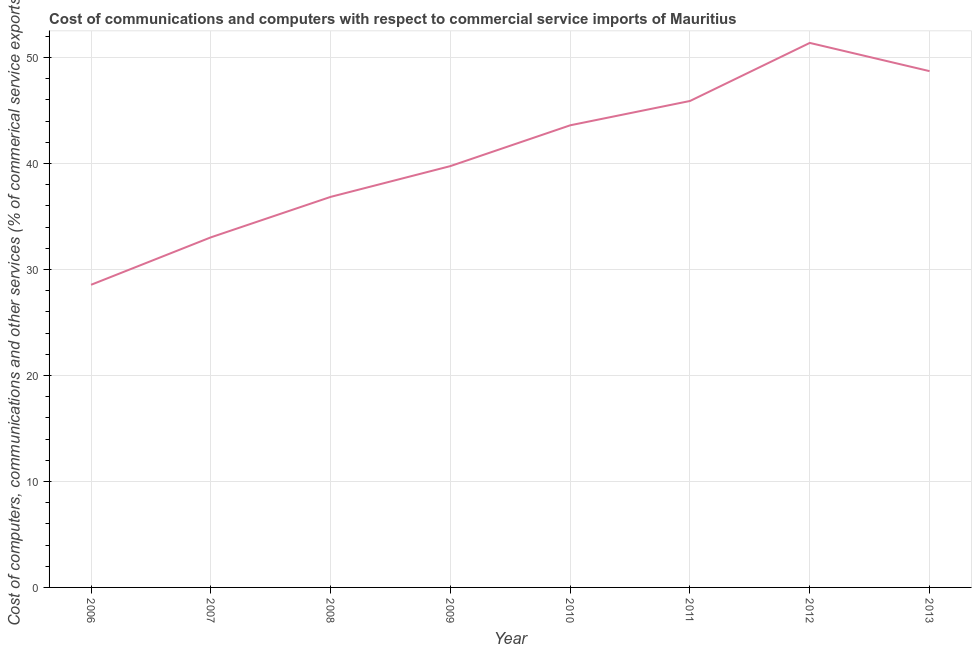What is the cost of communications in 2009?
Your answer should be very brief. 39.76. Across all years, what is the maximum  computer and other services?
Make the answer very short. 51.38. Across all years, what is the minimum  computer and other services?
Your response must be concise. 28.56. What is the sum of the  computer and other services?
Your response must be concise. 327.82. What is the difference between the cost of communications in 2011 and 2013?
Ensure brevity in your answer.  -2.82. What is the average cost of communications per year?
Provide a succinct answer. 40.98. What is the median cost of communications?
Give a very brief answer. 41.68. What is the ratio of the  computer and other services in 2009 to that in 2012?
Your response must be concise. 0.77. Is the cost of communications in 2007 less than that in 2009?
Keep it short and to the point. Yes. What is the difference between the highest and the second highest cost of communications?
Give a very brief answer. 2.66. Is the sum of the cost of communications in 2006 and 2010 greater than the maximum cost of communications across all years?
Your answer should be very brief. Yes. What is the difference between the highest and the lowest cost of communications?
Your response must be concise. 22.82. In how many years, is the cost of communications greater than the average cost of communications taken over all years?
Your answer should be very brief. 4. How many years are there in the graph?
Provide a short and direct response. 8. What is the difference between two consecutive major ticks on the Y-axis?
Keep it short and to the point. 10. What is the title of the graph?
Keep it short and to the point. Cost of communications and computers with respect to commercial service imports of Mauritius. What is the label or title of the X-axis?
Offer a very short reply. Year. What is the label or title of the Y-axis?
Offer a very short reply. Cost of computers, communications and other services (% of commerical service exports). What is the Cost of computers, communications and other services (% of commerical service exports) of 2006?
Provide a succinct answer. 28.56. What is the Cost of computers, communications and other services (% of commerical service exports) of 2007?
Your answer should be compact. 33.04. What is the Cost of computers, communications and other services (% of commerical service exports) of 2008?
Offer a very short reply. 36.85. What is the Cost of computers, communications and other services (% of commerical service exports) of 2009?
Provide a succinct answer. 39.76. What is the Cost of computers, communications and other services (% of commerical service exports) in 2010?
Give a very brief answer. 43.61. What is the Cost of computers, communications and other services (% of commerical service exports) in 2011?
Give a very brief answer. 45.9. What is the Cost of computers, communications and other services (% of commerical service exports) in 2012?
Your answer should be compact. 51.38. What is the Cost of computers, communications and other services (% of commerical service exports) of 2013?
Offer a very short reply. 48.72. What is the difference between the Cost of computers, communications and other services (% of commerical service exports) in 2006 and 2007?
Keep it short and to the point. -4.48. What is the difference between the Cost of computers, communications and other services (% of commerical service exports) in 2006 and 2008?
Offer a terse response. -8.3. What is the difference between the Cost of computers, communications and other services (% of commerical service exports) in 2006 and 2009?
Provide a short and direct response. -11.2. What is the difference between the Cost of computers, communications and other services (% of commerical service exports) in 2006 and 2010?
Keep it short and to the point. -15.05. What is the difference between the Cost of computers, communications and other services (% of commerical service exports) in 2006 and 2011?
Your answer should be very brief. -17.35. What is the difference between the Cost of computers, communications and other services (% of commerical service exports) in 2006 and 2012?
Your answer should be very brief. -22.82. What is the difference between the Cost of computers, communications and other services (% of commerical service exports) in 2006 and 2013?
Offer a terse response. -20.16. What is the difference between the Cost of computers, communications and other services (% of commerical service exports) in 2007 and 2008?
Your answer should be compact. -3.82. What is the difference between the Cost of computers, communications and other services (% of commerical service exports) in 2007 and 2009?
Ensure brevity in your answer.  -6.72. What is the difference between the Cost of computers, communications and other services (% of commerical service exports) in 2007 and 2010?
Your response must be concise. -10.57. What is the difference between the Cost of computers, communications and other services (% of commerical service exports) in 2007 and 2011?
Make the answer very short. -12.87. What is the difference between the Cost of computers, communications and other services (% of commerical service exports) in 2007 and 2012?
Your response must be concise. -18.35. What is the difference between the Cost of computers, communications and other services (% of commerical service exports) in 2007 and 2013?
Your response must be concise. -15.68. What is the difference between the Cost of computers, communications and other services (% of commerical service exports) in 2008 and 2009?
Your answer should be very brief. -2.91. What is the difference between the Cost of computers, communications and other services (% of commerical service exports) in 2008 and 2010?
Provide a succinct answer. -6.75. What is the difference between the Cost of computers, communications and other services (% of commerical service exports) in 2008 and 2011?
Provide a short and direct response. -9.05. What is the difference between the Cost of computers, communications and other services (% of commerical service exports) in 2008 and 2012?
Ensure brevity in your answer.  -14.53. What is the difference between the Cost of computers, communications and other services (% of commerical service exports) in 2008 and 2013?
Ensure brevity in your answer.  -11.87. What is the difference between the Cost of computers, communications and other services (% of commerical service exports) in 2009 and 2010?
Your answer should be very brief. -3.85. What is the difference between the Cost of computers, communications and other services (% of commerical service exports) in 2009 and 2011?
Offer a terse response. -6.14. What is the difference between the Cost of computers, communications and other services (% of commerical service exports) in 2009 and 2012?
Your answer should be compact. -11.62. What is the difference between the Cost of computers, communications and other services (% of commerical service exports) in 2009 and 2013?
Ensure brevity in your answer.  -8.96. What is the difference between the Cost of computers, communications and other services (% of commerical service exports) in 2010 and 2011?
Keep it short and to the point. -2.3. What is the difference between the Cost of computers, communications and other services (% of commerical service exports) in 2010 and 2012?
Your response must be concise. -7.77. What is the difference between the Cost of computers, communications and other services (% of commerical service exports) in 2010 and 2013?
Provide a succinct answer. -5.11. What is the difference between the Cost of computers, communications and other services (% of commerical service exports) in 2011 and 2012?
Give a very brief answer. -5.48. What is the difference between the Cost of computers, communications and other services (% of commerical service exports) in 2011 and 2013?
Give a very brief answer. -2.82. What is the difference between the Cost of computers, communications and other services (% of commerical service exports) in 2012 and 2013?
Ensure brevity in your answer.  2.66. What is the ratio of the Cost of computers, communications and other services (% of commerical service exports) in 2006 to that in 2007?
Make the answer very short. 0.86. What is the ratio of the Cost of computers, communications and other services (% of commerical service exports) in 2006 to that in 2008?
Make the answer very short. 0.78. What is the ratio of the Cost of computers, communications and other services (% of commerical service exports) in 2006 to that in 2009?
Offer a very short reply. 0.72. What is the ratio of the Cost of computers, communications and other services (% of commerical service exports) in 2006 to that in 2010?
Your answer should be compact. 0.66. What is the ratio of the Cost of computers, communications and other services (% of commerical service exports) in 2006 to that in 2011?
Your response must be concise. 0.62. What is the ratio of the Cost of computers, communications and other services (% of commerical service exports) in 2006 to that in 2012?
Your answer should be compact. 0.56. What is the ratio of the Cost of computers, communications and other services (% of commerical service exports) in 2006 to that in 2013?
Give a very brief answer. 0.59. What is the ratio of the Cost of computers, communications and other services (% of commerical service exports) in 2007 to that in 2008?
Make the answer very short. 0.9. What is the ratio of the Cost of computers, communications and other services (% of commerical service exports) in 2007 to that in 2009?
Give a very brief answer. 0.83. What is the ratio of the Cost of computers, communications and other services (% of commerical service exports) in 2007 to that in 2010?
Make the answer very short. 0.76. What is the ratio of the Cost of computers, communications and other services (% of commerical service exports) in 2007 to that in 2011?
Provide a short and direct response. 0.72. What is the ratio of the Cost of computers, communications and other services (% of commerical service exports) in 2007 to that in 2012?
Offer a very short reply. 0.64. What is the ratio of the Cost of computers, communications and other services (% of commerical service exports) in 2007 to that in 2013?
Offer a very short reply. 0.68. What is the ratio of the Cost of computers, communications and other services (% of commerical service exports) in 2008 to that in 2009?
Ensure brevity in your answer.  0.93. What is the ratio of the Cost of computers, communications and other services (% of commerical service exports) in 2008 to that in 2010?
Offer a very short reply. 0.84. What is the ratio of the Cost of computers, communications and other services (% of commerical service exports) in 2008 to that in 2011?
Provide a short and direct response. 0.8. What is the ratio of the Cost of computers, communications and other services (% of commerical service exports) in 2008 to that in 2012?
Offer a very short reply. 0.72. What is the ratio of the Cost of computers, communications and other services (% of commerical service exports) in 2008 to that in 2013?
Offer a very short reply. 0.76. What is the ratio of the Cost of computers, communications and other services (% of commerical service exports) in 2009 to that in 2010?
Your answer should be compact. 0.91. What is the ratio of the Cost of computers, communications and other services (% of commerical service exports) in 2009 to that in 2011?
Make the answer very short. 0.87. What is the ratio of the Cost of computers, communications and other services (% of commerical service exports) in 2009 to that in 2012?
Give a very brief answer. 0.77. What is the ratio of the Cost of computers, communications and other services (% of commerical service exports) in 2009 to that in 2013?
Offer a terse response. 0.82. What is the ratio of the Cost of computers, communications and other services (% of commerical service exports) in 2010 to that in 2012?
Offer a very short reply. 0.85. What is the ratio of the Cost of computers, communications and other services (% of commerical service exports) in 2010 to that in 2013?
Ensure brevity in your answer.  0.9. What is the ratio of the Cost of computers, communications and other services (% of commerical service exports) in 2011 to that in 2012?
Your response must be concise. 0.89. What is the ratio of the Cost of computers, communications and other services (% of commerical service exports) in 2011 to that in 2013?
Your answer should be very brief. 0.94. What is the ratio of the Cost of computers, communications and other services (% of commerical service exports) in 2012 to that in 2013?
Make the answer very short. 1.05. 